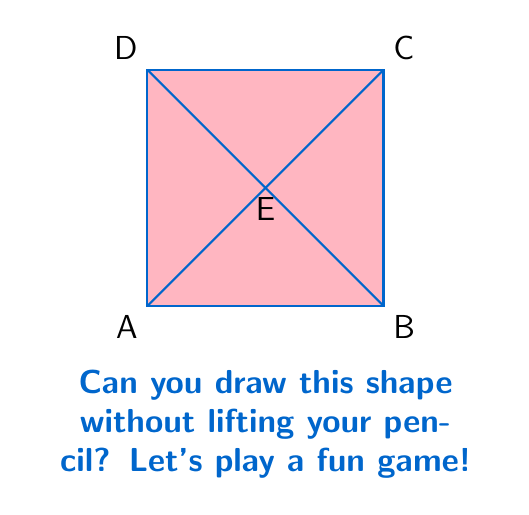Solve this math problem. Let's think about this step-by-step:

1) First, we need to understand what makes a shape drawable without lifting the pencil. This is related to a concept in math called Eulerian paths.

2) A shape can be drawn without lifting the pencil if:
   - All vertices (corner points) have an even number of lines connected to them, or
   - Exactly two vertices have an odd number of lines, and all others have an even number.

3) Let's count the number of lines connected to each point:
   - Point A: 3 lines
   - Point B: 3 lines
   - Point C: 3 lines
   - Point D: 3 lines
   - Point E: 4 lines

4) We can see that four points (A, B, C, and D) have an odd number of lines (3), and only one point (E) has an even number (4).

5) This doesn't meet either of our conditions from step 2. We need either all even or exactly two odd.

6) Therefore, it's not possible to draw this shape without lifting the pencil.

Remember, in math, sometimes finding out something is not possible is just as important as finding out what is possible!
Answer: No 